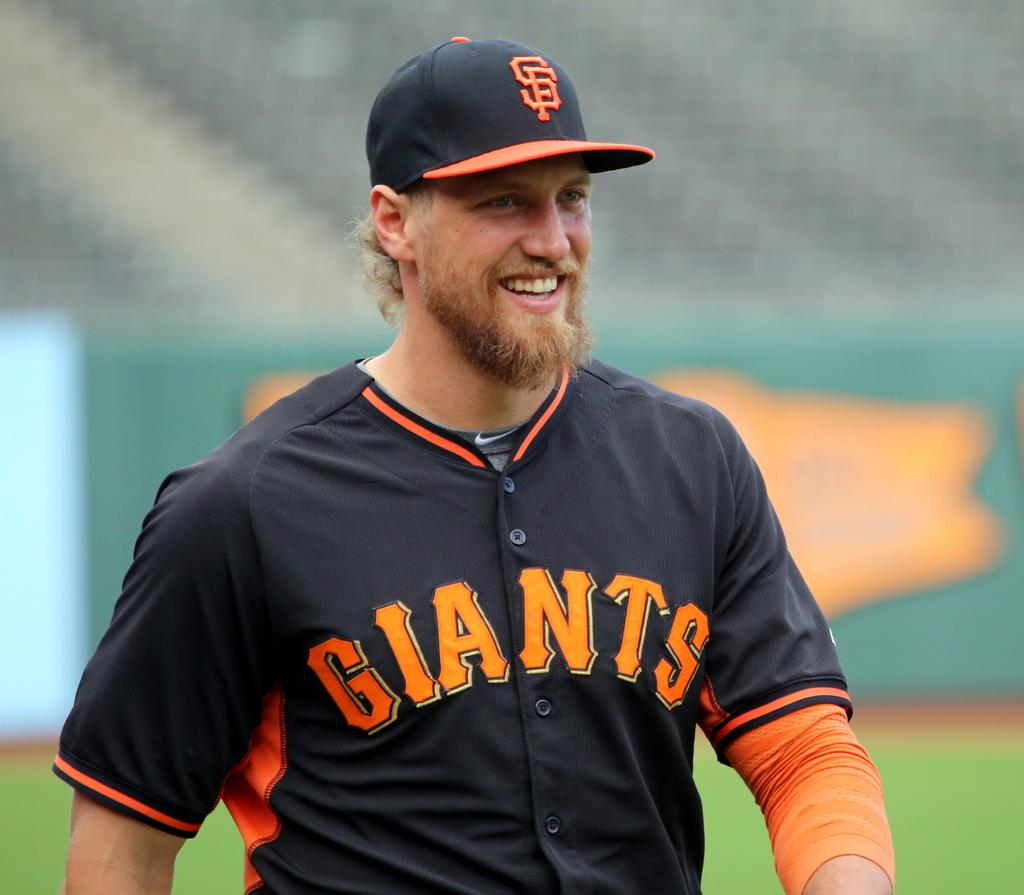<image>
Render a clear and concise summary of the photo. A Giants player stands on the field in his jersey smiling 